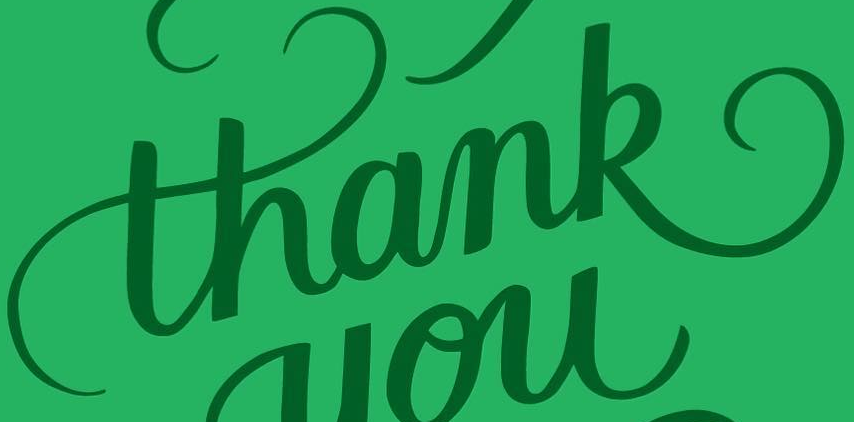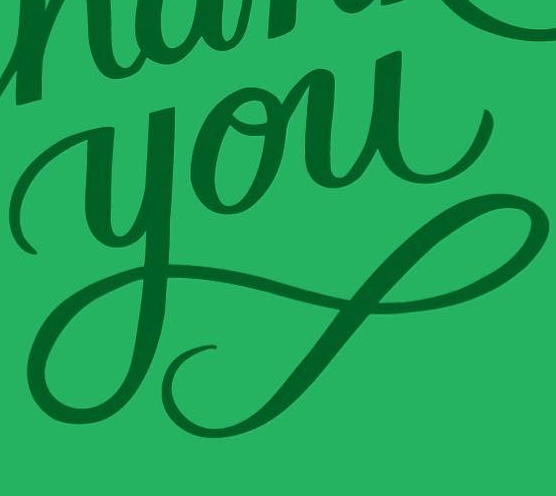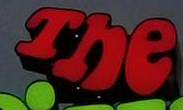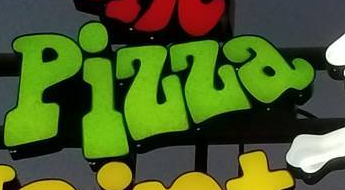What words are shown in these images in order, separated by a semicolon? thank; you; The; Pizza 